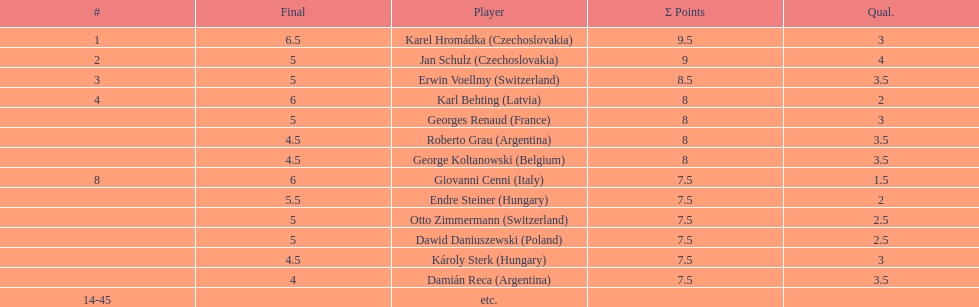Who was the top scorer from switzerland? Erwin Voellmy. 